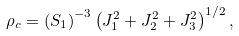Convert formula to latex. <formula><loc_0><loc_0><loc_500><loc_500>\rho _ { c } = \left ( S _ { 1 } \right ) ^ { - 3 } \left ( J _ { 1 } ^ { 2 } + J _ { 2 } ^ { 2 } + J _ { 3 } ^ { 2 } \right ) ^ { 1 / 2 } ,</formula> 